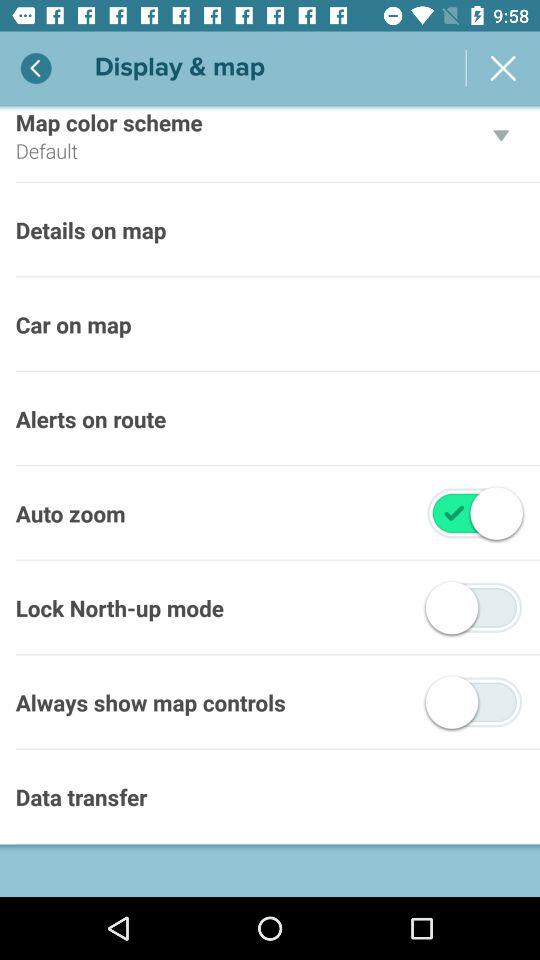What is the status of "Auto zoom"? The status is "on". 